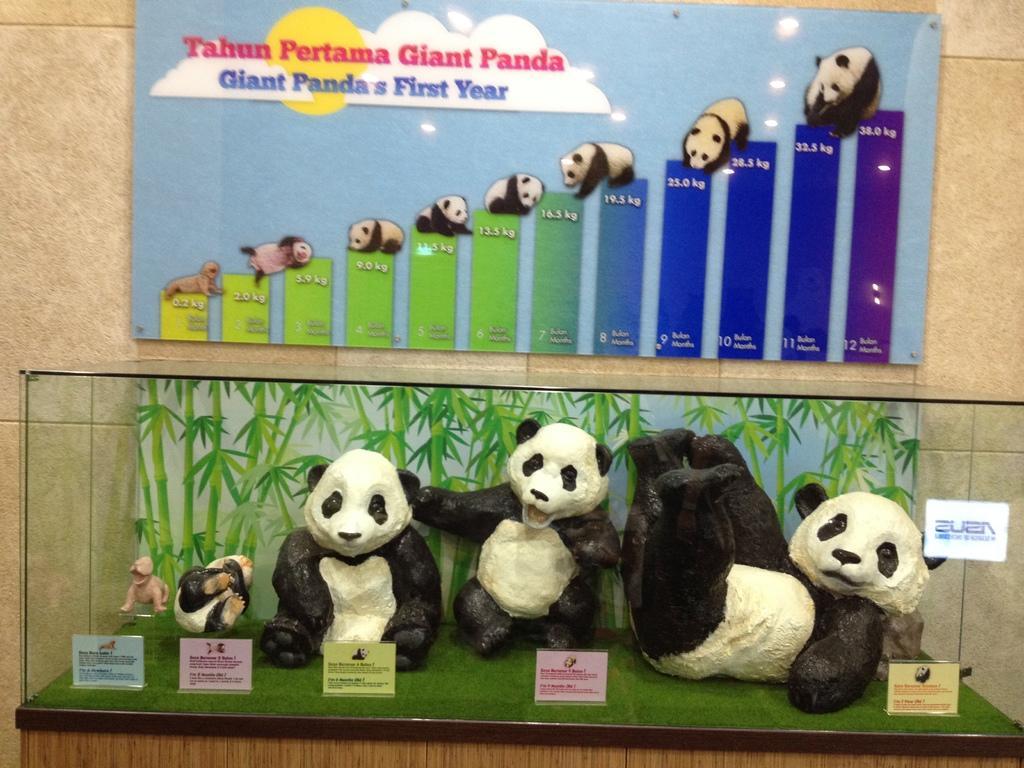Can you describe this image briefly? In this picture i can see statues of pandas in a mirror box. In the background i can see a wall on which a board is attached to it. 